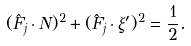Convert formula to latex. <formula><loc_0><loc_0><loc_500><loc_500>( \hat { F } _ { j } \cdot N ) ^ { 2 } + ( \hat { F } _ { j } \cdot \xi ^ { \prime } ) ^ { 2 } = \frac { 1 } { 2 } .</formula> 